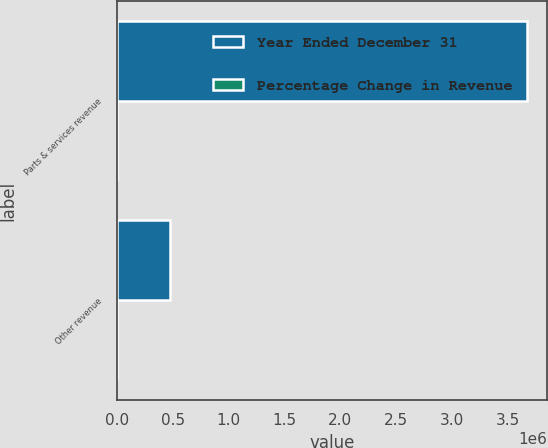Convert chart to OTSL. <chart><loc_0><loc_0><loc_500><loc_500><stacked_bar_chart><ecel><fcel>Parts & services revenue<fcel>Other revenue<nl><fcel>Year Ended December 31<fcel>3.6716e+06<fcel>474403<nl><fcel>Percentage Change in Revenue<fcel>5.6<fcel>28.8<nl></chart> 